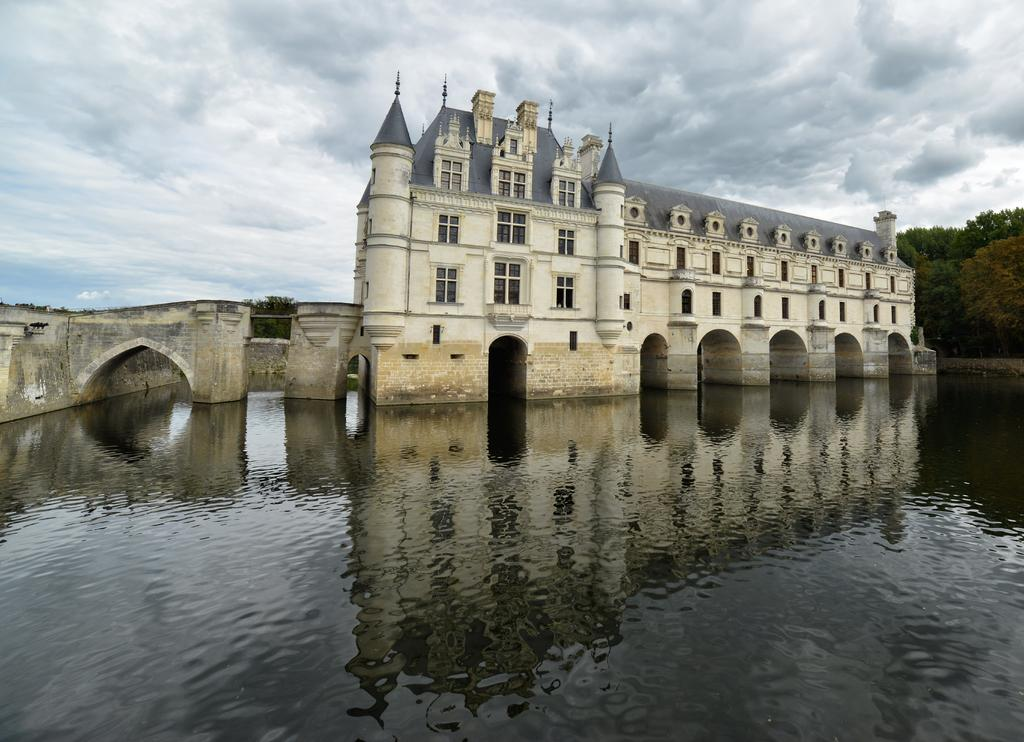What is the main subject of the image? There is a building in the water in the image. What can be seen behind the building? Trees are visible behind the building. What is visible above the building and trees? The sky is visible in the image. What is present in the sky? Clouds are present in the sky. What type of insect can be seen performing on the stage in the image? There is no stage or insect present in the image. 